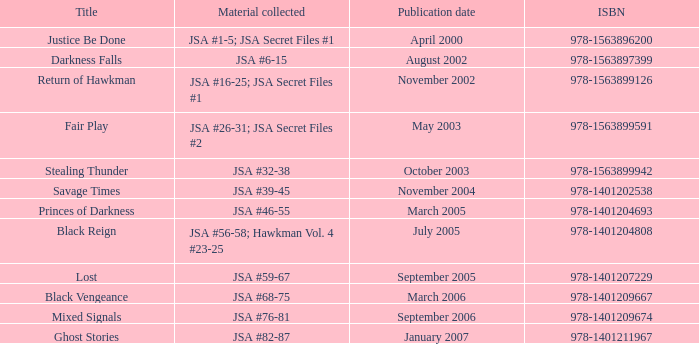How many Volume Numbers have the title of Darkness Falls? 2.0. 